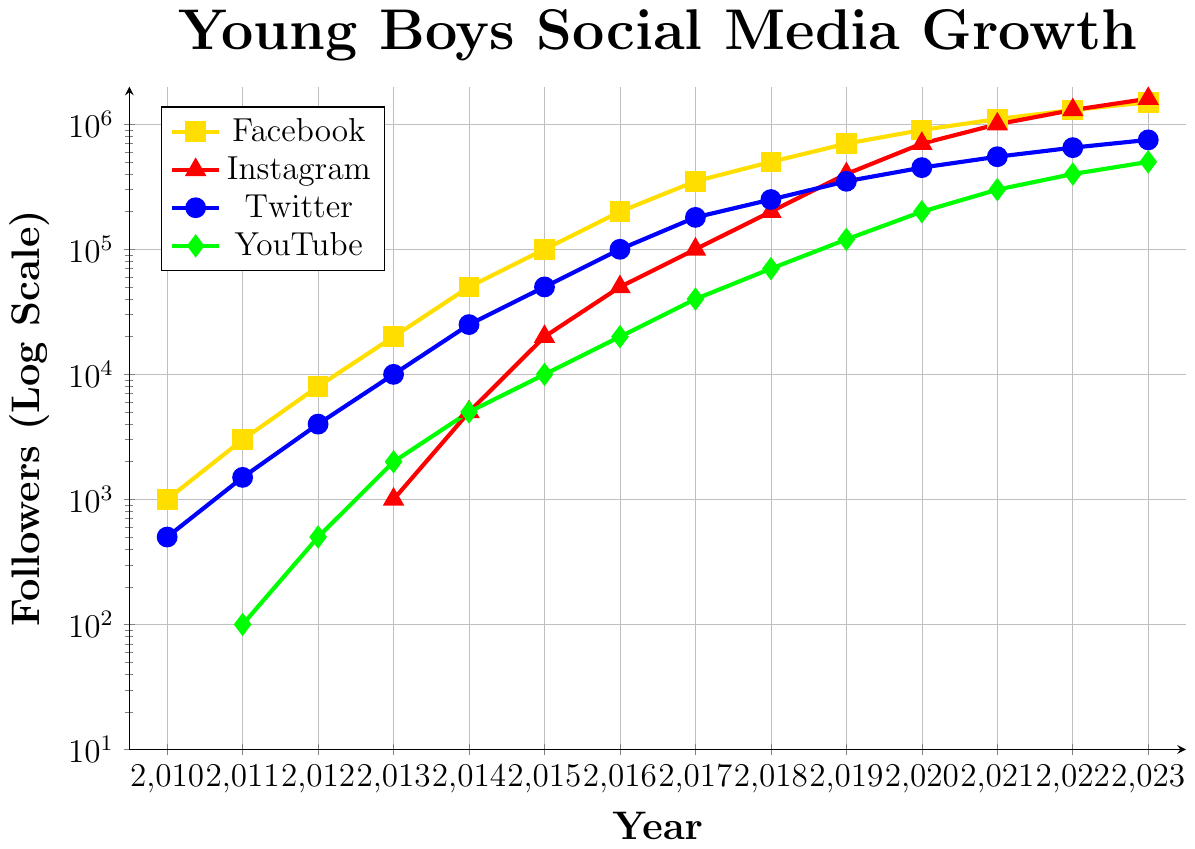What is the platform with the highest followers in 2023? From the chart, look at the data points for the year 2023 across all platforms. Instagram has the highest visual marker at the top.
Answer: Instagram Which platform had the fastest follower growth from 2013 to 2015? From 2013 to 2015, compare the distance between the data points for each platform. Instagram's data points jump from 1,000 to 20,000, a significant increase in that time frame.
Answer: Instagram By what factor did YouTube followers increase from 2011 to 2023? YouTube followers in 2011 were 100, and in 2023, they were 500,000. The factor increase is 500,000 / 100 = 5,000.
Answer: 5,000 What is the difference in the number of Twitter followers between 2020 and 2015? In 2015, Twitter had 50,000 followers, and in 2020, it had 450,000. The difference is 450,000 - 50,000 = 400,000.
Answer: 400,000 Between which two years did Facebook see the largest increase in followers? Look at the steepest slope between consecutive years for Facebook. The increase between 2019 and 2020 appears the largest, from 700,000 to 900,000, an increase of 200,000 followers.
Answer: 2019 and 2020 How did Instagram's followers compare to Facebook's followers in 2022? In 2022, both Instagram and Facebook have data points visually aligned at approximately the same height. By examining the legend, both have 1,300,000 followers.
Answer: Equal What is the average number of YouTube followers from 2018 to 2023? The YouTube data points from 2018 to 2023 are (70,000, 120,000, 200,000, 300,000, 400,000, 500,000). Sum these: 70,000 + 120,000 + 200,000 + 300,000 + 400,000 + 500,000 = 1,590,000. The average is 1,590,000 / 6 = 265,000.
Answer: 265,000 In which year did Twitter followers first reach 100,000? Follow the Twitter data points until reaching 100,000. This occurs in 2016.
Answer: 2016 What trend is observed in Facebook followers from 2010 to 2023? The Facebook followers consistently increase each year, showing exponential growth, which is evident from the log scale where each year, the followers' count significantly increases.
Answer: Exponential growth 